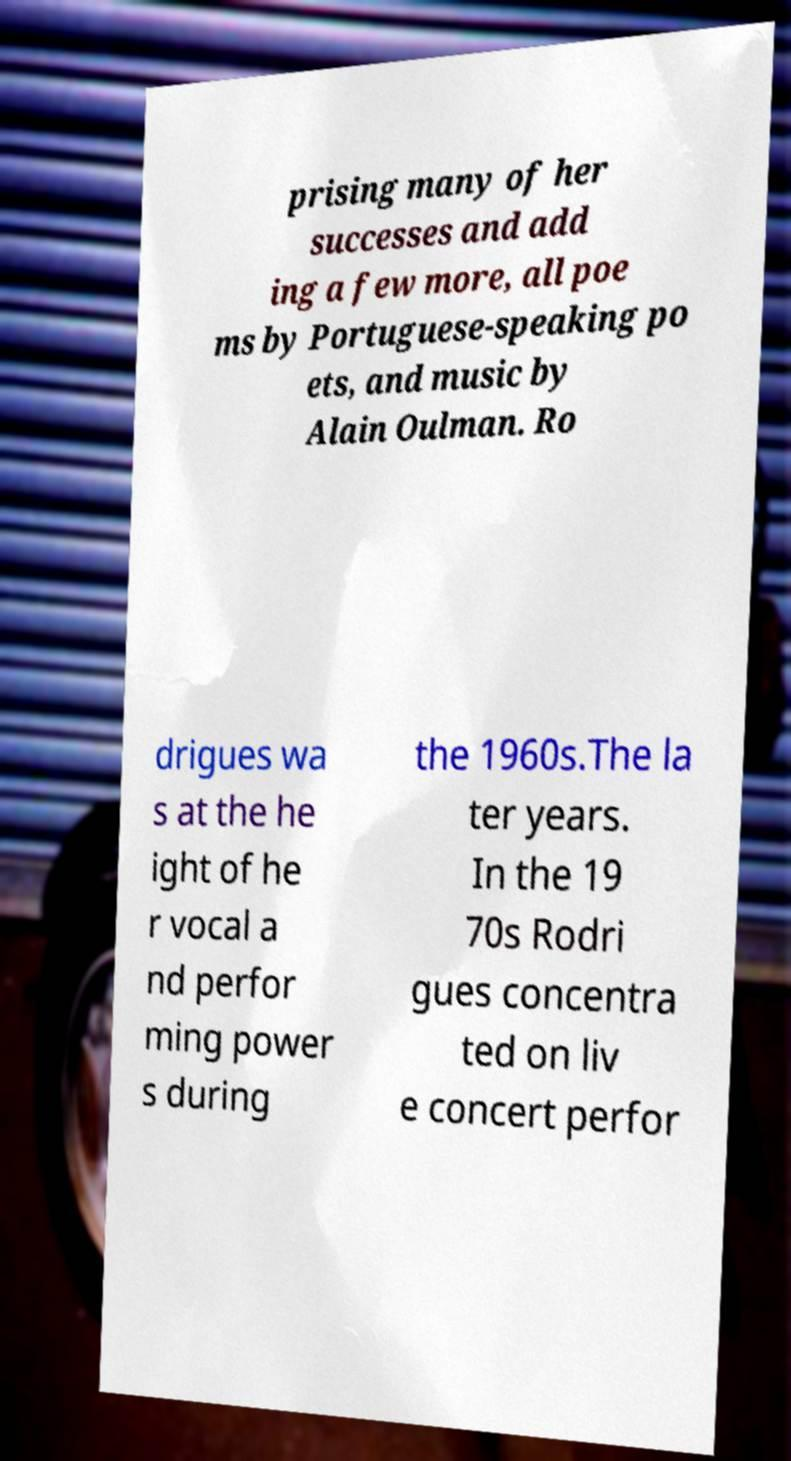There's text embedded in this image that I need extracted. Can you transcribe it verbatim? prising many of her successes and add ing a few more, all poe ms by Portuguese-speaking po ets, and music by Alain Oulman. Ro drigues wa s at the he ight of he r vocal a nd perfor ming power s during the 1960s.The la ter years. In the 19 70s Rodri gues concentra ted on liv e concert perfor 